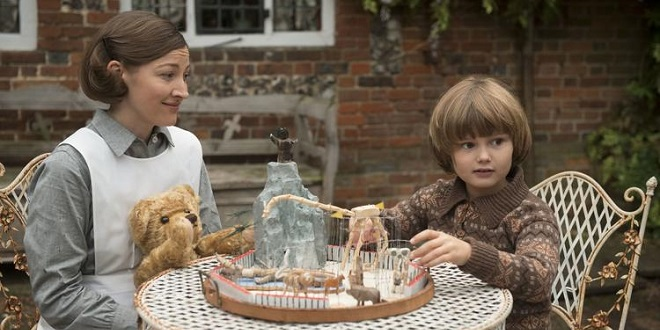What are the key elements in this picture? In the image, an actress, who seems to be Kelly Macdonald, is captured enjoying a charming moment with a young boy. They are seated around a quaint white table that's embellished with a teddy bear and an intricately designed model featuring animals and a small carousel. Kelly, wearing a white apron, has a warm smile directed at the boy, who is dressed in a brown patterned shirt. His eyes are filled with curiosity as he engages with the toy carousel on the table. The setting is completed with a rustic brick wall and a quaint window in the background, adding a nostalgic and homely charm to the scene. 